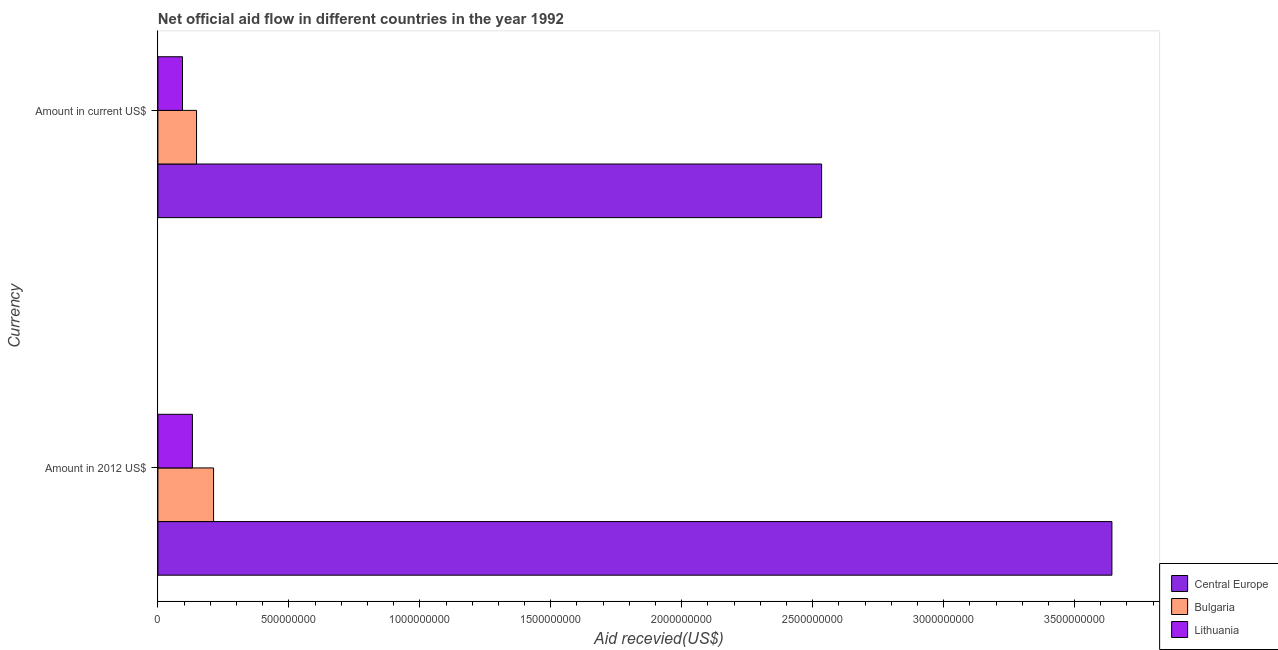How many bars are there on the 1st tick from the top?
Your response must be concise. 3. How many bars are there on the 2nd tick from the bottom?
Provide a succinct answer. 3. What is the label of the 1st group of bars from the top?
Keep it short and to the point. Amount in current US$. What is the amount of aid received(expressed in 2012 us$) in Central Europe?
Offer a very short reply. 3.64e+09. Across all countries, what is the maximum amount of aid received(expressed in 2012 us$)?
Provide a short and direct response. 3.64e+09. Across all countries, what is the minimum amount of aid received(expressed in 2012 us$)?
Offer a terse response. 1.32e+08. In which country was the amount of aid received(expressed in 2012 us$) maximum?
Keep it short and to the point. Central Europe. In which country was the amount of aid received(expressed in 2012 us$) minimum?
Your response must be concise. Lithuania. What is the total amount of aid received(expressed in us$) in the graph?
Offer a very short reply. 2.78e+09. What is the difference between the amount of aid received(expressed in us$) in Central Europe and that in Lithuania?
Your answer should be very brief. 2.44e+09. What is the difference between the amount of aid received(expressed in us$) in Central Europe and the amount of aid received(expressed in 2012 us$) in Bulgaria?
Offer a very short reply. 2.32e+09. What is the average amount of aid received(expressed in 2012 us$) per country?
Offer a very short reply. 1.33e+09. What is the difference between the amount of aid received(expressed in us$) and amount of aid received(expressed in 2012 us$) in Central Europe?
Make the answer very short. -1.11e+09. In how many countries, is the amount of aid received(expressed in 2012 us$) greater than 3400000000 US$?
Keep it short and to the point. 1. What is the ratio of the amount of aid received(expressed in 2012 us$) in Central Europe to that in Lithuania?
Provide a short and direct response. 27.65. What does the 2nd bar from the top in Amount in 2012 US$ represents?
Offer a very short reply. Bulgaria. What does the 3rd bar from the bottom in Amount in 2012 US$ represents?
Your response must be concise. Lithuania. How many bars are there?
Keep it short and to the point. 6. Are all the bars in the graph horizontal?
Provide a succinct answer. Yes. How many countries are there in the graph?
Offer a terse response. 3. What is the difference between two consecutive major ticks on the X-axis?
Offer a very short reply. 5.00e+08. Does the graph contain grids?
Ensure brevity in your answer.  No. Where does the legend appear in the graph?
Ensure brevity in your answer.  Bottom right. How many legend labels are there?
Give a very brief answer. 3. How are the legend labels stacked?
Make the answer very short. Vertical. What is the title of the graph?
Your answer should be compact. Net official aid flow in different countries in the year 1992. Does "Iraq" appear as one of the legend labels in the graph?
Your response must be concise. No. What is the label or title of the X-axis?
Provide a short and direct response. Aid recevied(US$). What is the label or title of the Y-axis?
Give a very brief answer. Currency. What is the Aid recevied(US$) of Central Europe in Amount in 2012 US$?
Provide a short and direct response. 3.64e+09. What is the Aid recevied(US$) in Bulgaria in Amount in 2012 US$?
Provide a short and direct response. 2.13e+08. What is the Aid recevied(US$) of Lithuania in Amount in 2012 US$?
Offer a terse response. 1.32e+08. What is the Aid recevied(US$) of Central Europe in Amount in current US$?
Provide a short and direct response. 2.53e+09. What is the Aid recevied(US$) in Bulgaria in Amount in current US$?
Offer a very short reply. 1.48e+08. What is the Aid recevied(US$) in Lithuania in Amount in current US$?
Provide a succinct answer. 9.38e+07. Across all Currency, what is the maximum Aid recevied(US$) of Central Europe?
Offer a terse response. 3.64e+09. Across all Currency, what is the maximum Aid recevied(US$) of Bulgaria?
Offer a terse response. 2.13e+08. Across all Currency, what is the maximum Aid recevied(US$) of Lithuania?
Provide a succinct answer. 1.32e+08. Across all Currency, what is the minimum Aid recevied(US$) in Central Europe?
Give a very brief answer. 2.53e+09. Across all Currency, what is the minimum Aid recevied(US$) of Bulgaria?
Offer a very short reply. 1.48e+08. Across all Currency, what is the minimum Aid recevied(US$) of Lithuania?
Ensure brevity in your answer.  9.38e+07. What is the total Aid recevied(US$) in Central Europe in the graph?
Give a very brief answer. 6.18e+09. What is the total Aid recevied(US$) of Bulgaria in the graph?
Your answer should be very brief. 3.60e+08. What is the total Aid recevied(US$) in Lithuania in the graph?
Keep it short and to the point. 2.26e+08. What is the difference between the Aid recevied(US$) of Central Europe in Amount in 2012 US$ and that in Amount in current US$?
Keep it short and to the point. 1.11e+09. What is the difference between the Aid recevied(US$) in Bulgaria in Amount in 2012 US$ and that in Amount in current US$?
Your answer should be compact. 6.51e+07. What is the difference between the Aid recevied(US$) in Lithuania in Amount in 2012 US$ and that in Amount in current US$?
Keep it short and to the point. 3.79e+07. What is the difference between the Aid recevied(US$) of Central Europe in Amount in 2012 US$ and the Aid recevied(US$) of Bulgaria in Amount in current US$?
Your response must be concise. 3.50e+09. What is the difference between the Aid recevied(US$) of Central Europe in Amount in 2012 US$ and the Aid recevied(US$) of Lithuania in Amount in current US$?
Your answer should be compact. 3.55e+09. What is the difference between the Aid recevied(US$) in Bulgaria in Amount in 2012 US$ and the Aid recevied(US$) in Lithuania in Amount in current US$?
Your response must be concise. 1.19e+08. What is the average Aid recevied(US$) of Central Europe per Currency?
Offer a terse response. 3.09e+09. What is the average Aid recevied(US$) in Bulgaria per Currency?
Make the answer very short. 1.80e+08. What is the average Aid recevied(US$) in Lithuania per Currency?
Your response must be concise. 1.13e+08. What is the difference between the Aid recevied(US$) in Central Europe and Aid recevied(US$) in Bulgaria in Amount in 2012 US$?
Offer a very short reply. 3.43e+09. What is the difference between the Aid recevied(US$) of Central Europe and Aid recevied(US$) of Lithuania in Amount in 2012 US$?
Provide a short and direct response. 3.51e+09. What is the difference between the Aid recevied(US$) of Bulgaria and Aid recevied(US$) of Lithuania in Amount in 2012 US$?
Your response must be concise. 8.08e+07. What is the difference between the Aid recevied(US$) in Central Europe and Aid recevied(US$) in Bulgaria in Amount in current US$?
Your answer should be very brief. 2.39e+09. What is the difference between the Aid recevied(US$) of Central Europe and Aid recevied(US$) of Lithuania in Amount in current US$?
Provide a short and direct response. 2.44e+09. What is the difference between the Aid recevied(US$) of Bulgaria and Aid recevied(US$) of Lithuania in Amount in current US$?
Ensure brevity in your answer.  5.37e+07. What is the ratio of the Aid recevied(US$) in Central Europe in Amount in 2012 US$ to that in Amount in current US$?
Keep it short and to the point. 1.44. What is the ratio of the Aid recevied(US$) in Bulgaria in Amount in 2012 US$ to that in Amount in current US$?
Your answer should be compact. 1.44. What is the ratio of the Aid recevied(US$) in Lithuania in Amount in 2012 US$ to that in Amount in current US$?
Provide a short and direct response. 1.4. What is the difference between the highest and the second highest Aid recevied(US$) in Central Europe?
Offer a very short reply. 1.11e+09. What is the difference between the highest and the second highest Aid recevied(US$) in Bulgaria?
Make the answer very short. 6.51e+07. What is the difference between the highest and the second highest Aid recevied(US$) of Lithuania?
Provide a short and direct response. 3.79e+07. What is the difference between the highest and the lowest Aid recevied(US$) in Central Europe?
Offer a terse response. 1.11e+09. What is the difference between the highest and the lowest Aid recevied(US$) in Bulgaria?
Keep it short and to the point. 6.51e+07. What is the difference between the highest and the lowest Aid recevied(US$) in Lithuania?
Offer a terse response. 3.79e+07. 